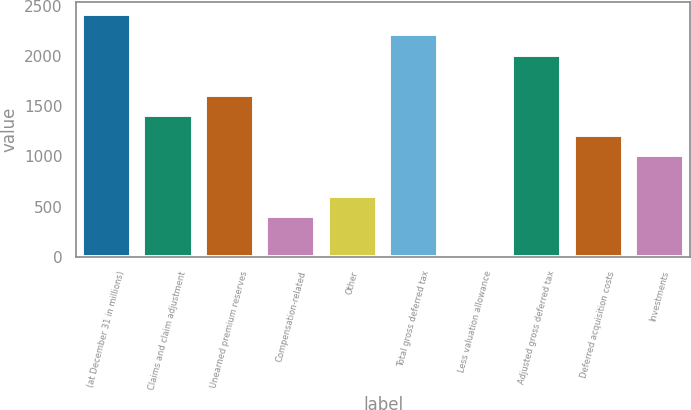Convert chart to OTSL. <chart><loc_0><loc_0><loc_500><loc_500><bar_chart><fcel>(at December 31 in millions)<fcel>Claims and claim adjustment<fcel>Unearned premium reserves<fcel>Compensation-related<fcel>Other<fcel>Total gross deferred tax<fcel>Less valuation allowance<fcel>Adjusted gross deferred tax<fcel>Deferred acquisition costs<fcel>Investments<nl><fcel>2418.6<fcel>1412.1<fcel>1613.4<fcel>405.6<fcel>606.9<fcel>2217.3<fcel>3<fcel>2016<fcel>1210.8<fcel>1009.5<nl></chart> 